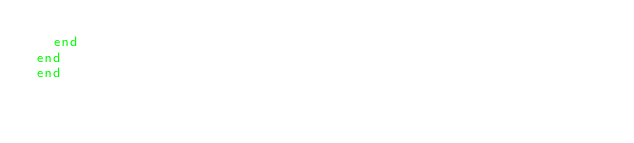Convert code to text. <code><loc_0><loc_0><loc_500><loc_500><_Ruby_>  end
end
end
</code> 